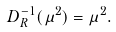<formula> <loc_0><loc_0><loc_500><loc_500>D _ { R } ^ { - 1 } ( \mu ^ { 2 } ) = \mu ^ { 2 } .</formula> 